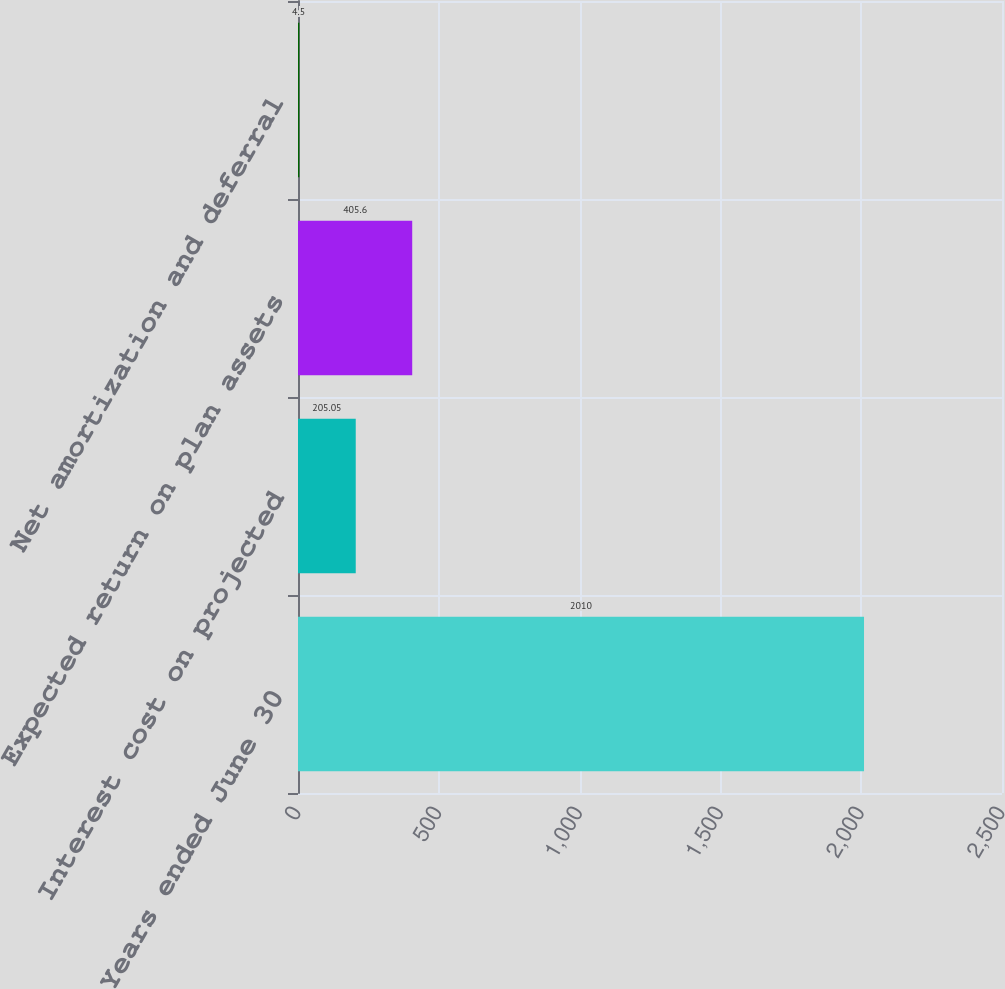Convert chart to OTSL. <chart><loc_0><loc_0><loc_500><loc_500><bar_chart><fcel>Years ended June 30<fcel>Interest cost on projected<fcel>Expected return on plan assets<fcel>Net amortization and deferral<nl><fcel>2010<fcel>205.05<fcel>405.6<fcel>4.5<nl></chart> 